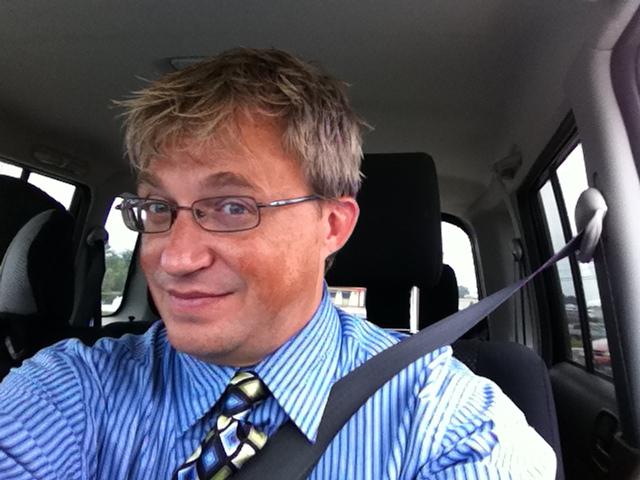Is this man wearing glasses?
Give a very brief answer. Yes. Does this person seem confident?
Concise answer only. Yes. Is this man fond of blue?
Concise answer only. Yes. Is he wearing a suit?
Concise answer only. No. IS this man taking a selfie?
Keep it brief. Yes. Is the man in a restaurant?
Write a very short answer. No. 